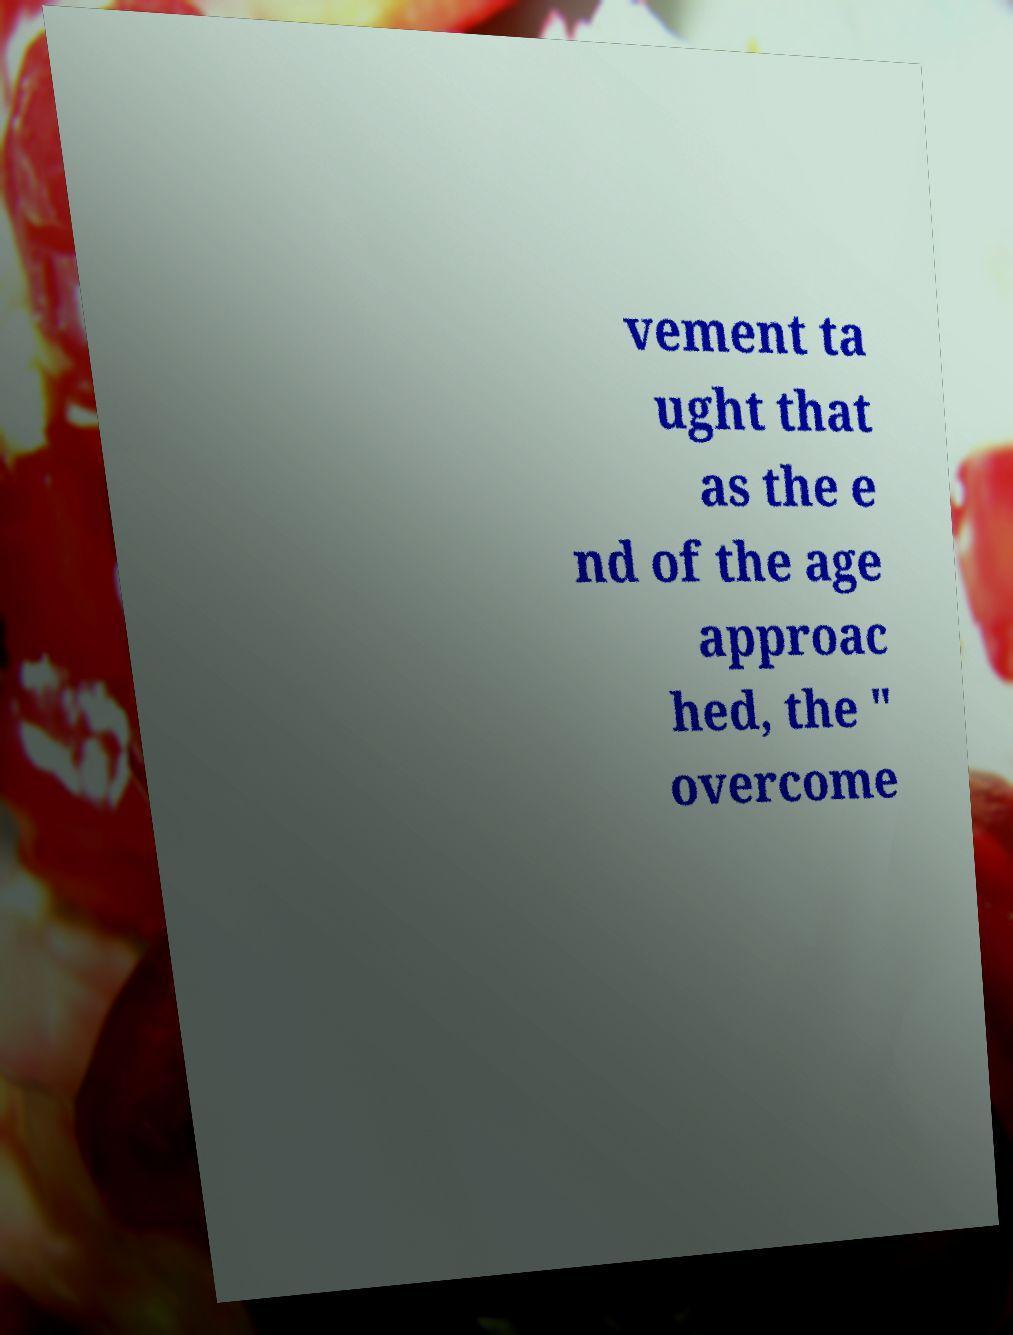Can you accurately transcribe the text from the provided image for me? vement ta ught that as the e nd of the age approac hed, the " overcome 